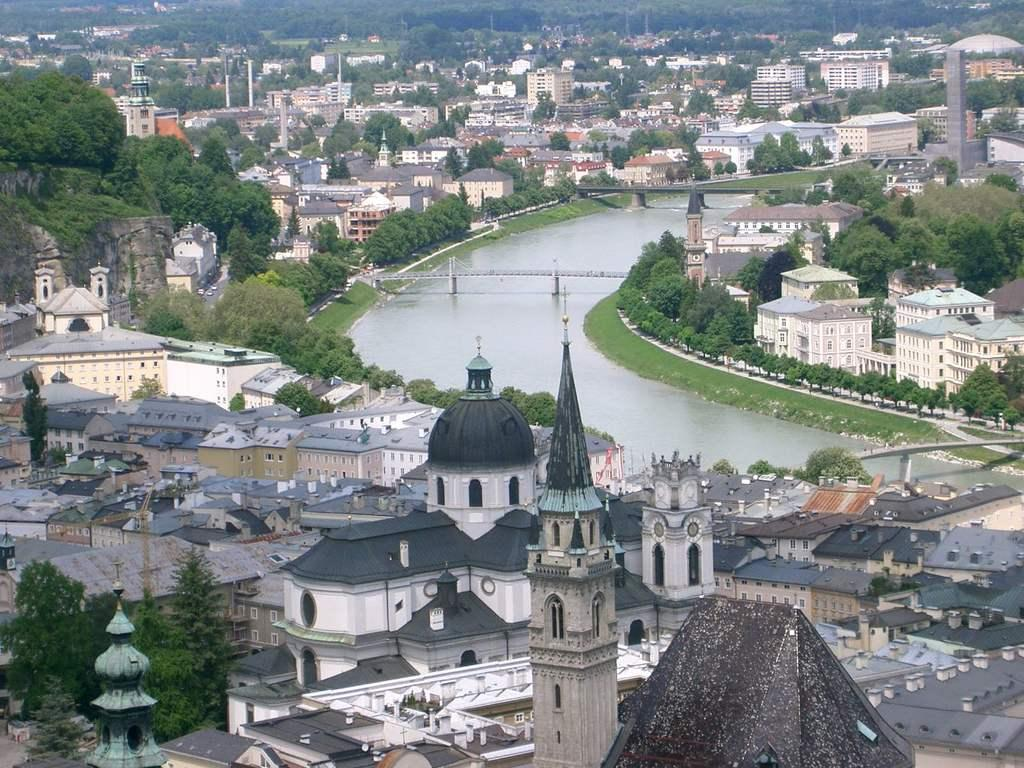What type of natural elements can be seen in the image? There are trees in the image. What type of man-made structures are visible in the image? There are buildings in the image. What is the main feature in the middle of the image? There is a canal bridge in the middle of the image. Are there any other bridges in the image? Yes, there is another bridge on the right side of the image. What type of store can be seen on the left side of the image? There is no store present in the image; it features trees, buildings, and bridges. What is the hour of the day depicted in the image? The provided facts do not give any information about the time of day, so it cannot be determined from the image. 